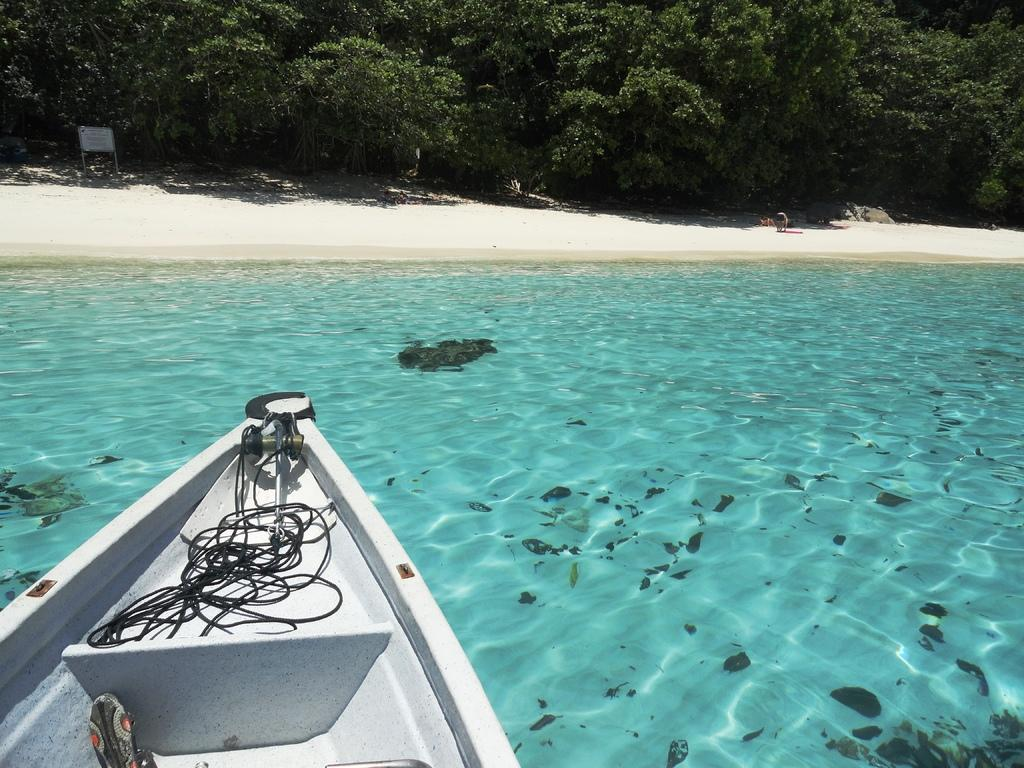What is the main subject of the image? The main subject of the image is a boat. Where is the boat located in the image? The boat is on the water in the image. What type of terrain can be seen in the image? There is sand in the image. What object is present in the image that might be used for standing or walking? There is a board in the image. What type of living creature is in the image? There is an animal in the image. What type of vegetation is visible in the image? There are trees in the image. What type of zebra can be seen impulsively jumping over the group of trees in the image? There is no zebra present in the image, nor is there any impulsive jumping or group of trees. 